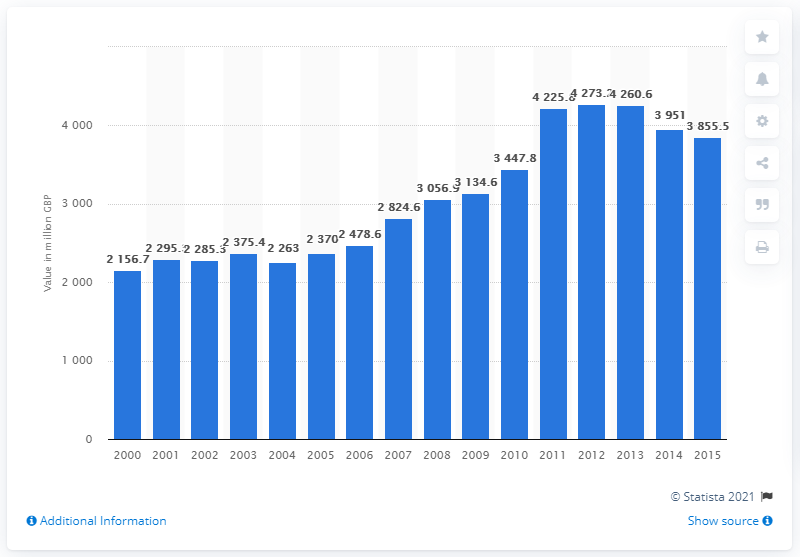Indicate a few pertinent items in this graphic. In 2012, the UK exported 4260.6 million British pounds worth of Scotch whisky. 